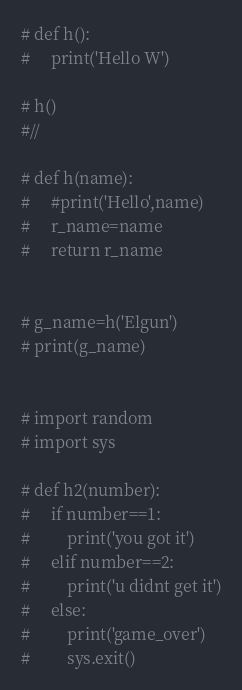<code> <loc_0><loc_0><loc_500><loc_500><_Python_># def h():
#     print('Hello W')

# h()
#//

# def h(name):
#     #print('Hello',name)
#     r_name=name
#     return r_name


# g_name=h('Elgun')
# print(g_name)


# import random
# import sys

# def h2(number):
#     if number==1:
#         print('you got it')
#     elif number==2:
#         print('u didnt get it')
#     else:
#         print('game_over')
#         sys.exit()
</code> 